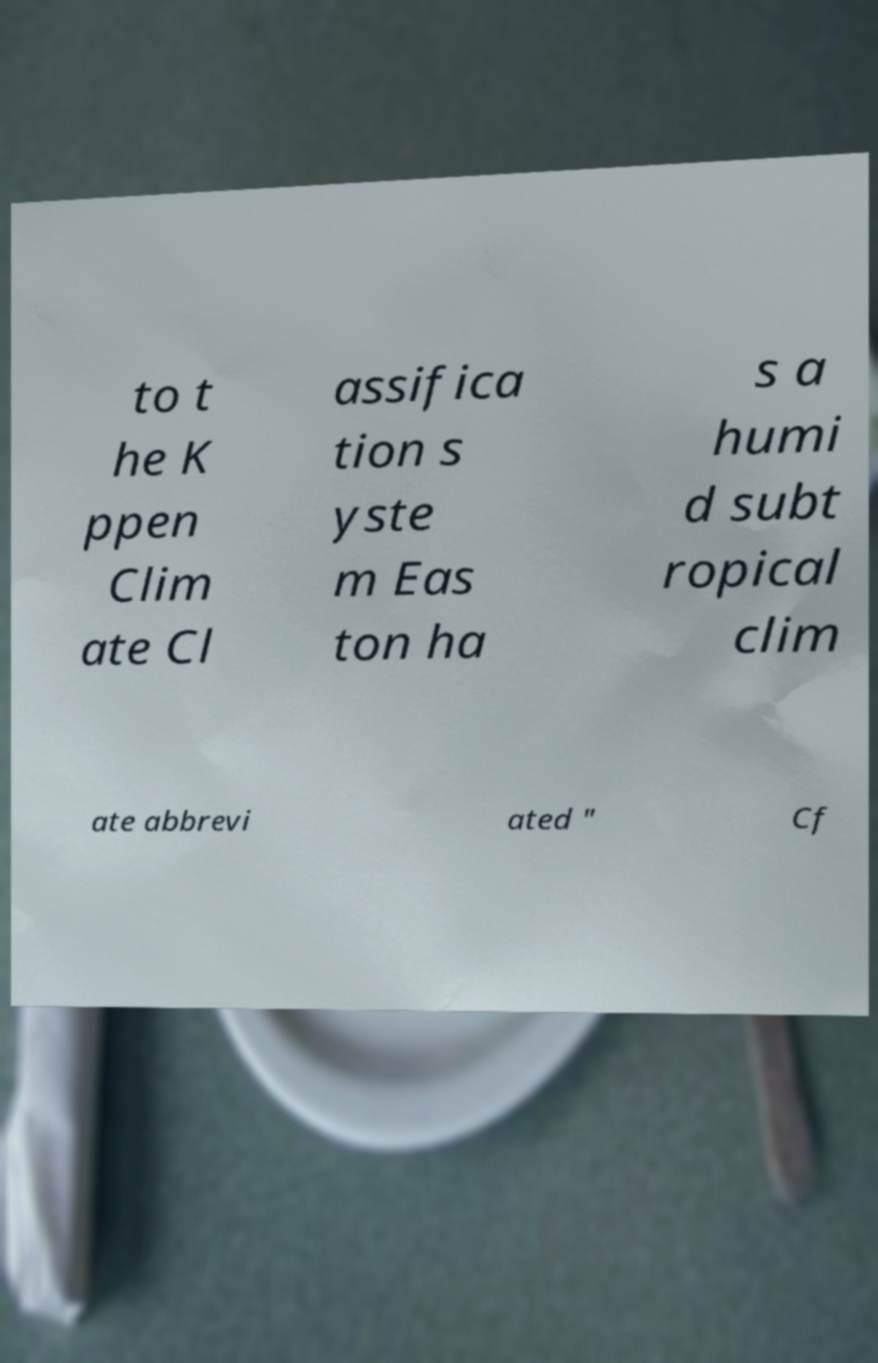Can you read and provide the text displayed in the image?This photo seems to have some interesting text. Can you extract and type it out for me? to t he K ppen Clim ate Cl assifica tion s yste m Eas ton ha s a humi d subt ropical clim ate abbrevi ated " Cf 